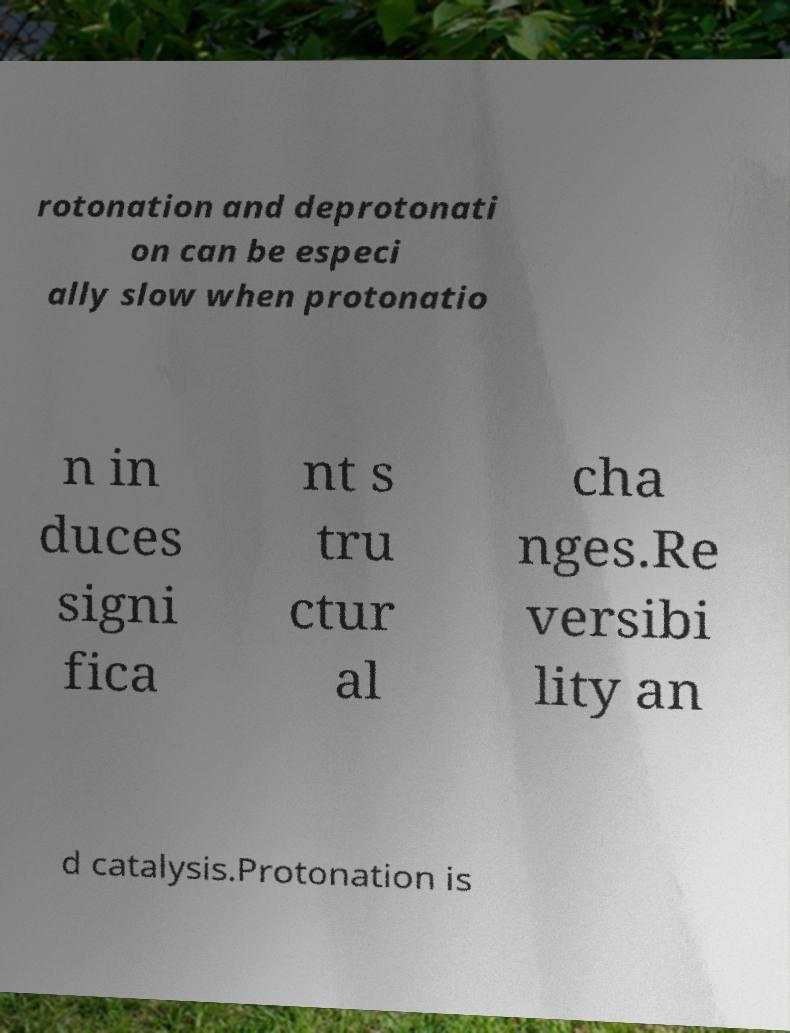Could you extract and type out the text from this image? rotonation and deprotonati on can be especi ally slow when protonatio n in duces signi fica nt s tru ctur al cha nges.Re versibi lity an d catalysis.Protonation is 